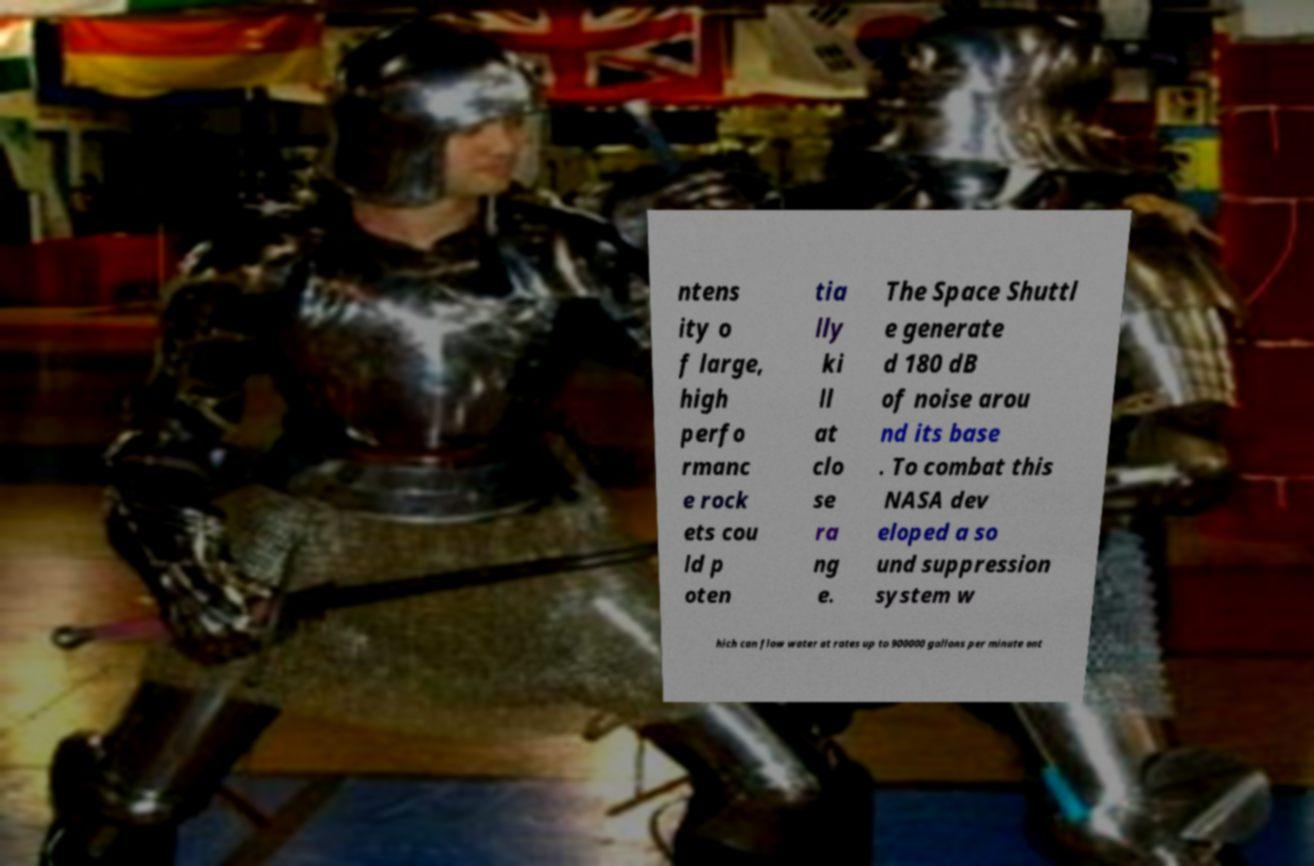I need the written content from this picture converted into text. Can you do that? ntens ity o f large, high perfo rmanc e rock ets cou ld p oten tia lly ki ll at clo se ra ng e. The Space Shuttl e generate d 180 dB of noise arou nd its base . To combat this NASA dev eloped a so und suppression system w hich can flow water at rates up to 900000 gallons per minute ont 